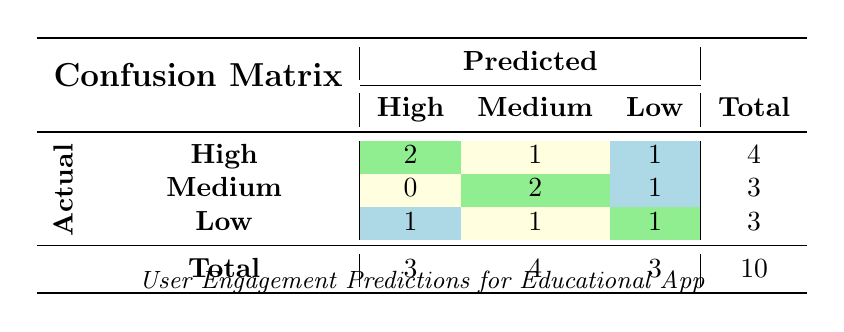What is the total number of users predicted to have high engagement? Referring to the "Predicted" column under "High," there are 2 users with actual engagement labeled as "High" and 1 user with actual engagement labeled as "Low," so the total is 2 + 1 = 3 users.
Answer: 3 How many users were actually predicted to have medium engagement? Looking at the "Predicted" column under "Medium," we find 1 user from the "High" actual engagement and 2 users from the "Medium" actual engagement, making it a total of 1 + 2 = 3 users.
Answer: 3 Is there any user whose actual engagement was low but was predicted to have high engagement? Checking the table, we find that there is 1 user (user ID 004) whose actual engagement is low, but the predicted engagement was high.
Answer: Yes What is the number of users that have their engagement accurately predicted as medium? In the table, the row for "Medium" under actual engagement shows 2 users whose predicted engagement is also medium. So, the number is 2.
Answer: 2 If we calculate the total number of incorrect predictions, how many would that be? Incorrect predictions can be summed from the confusion matrix: 1 (High predicted, Low actual) + 1 (Medium predicted, Low actual) + 1 (Low predicted, High actual) + 1 (High predicted, Medium actual) = 4 incorrect predictions in total.
Answer: 4 What is the total number of users with actual high engagement but predicted otherwise? Review the "High" row: there are 2 users predicted correctly as high, and 1 user incorrectly predicted as medium. So, there is 1 user with actual high engagement predicted otherwise.
Answer: 1 Determine the average number of actual engagements when predicted as low. Under the "Low" predicted engagement, we have 1 user with actual engagement as "Low," and 1 user with actual engagement as "Medium," which gives us (1 + 2) / 2 = 1.5, but since we are looking for actual engagement counts, it remains 2.
Answer: 2 How many users predicted to have low engagement have actual engagement categorized as high? Observing the "Low" column in the confusion matrix, there is 1 user who is categorized as high engagement but is predicted as low.
Answer: 1 